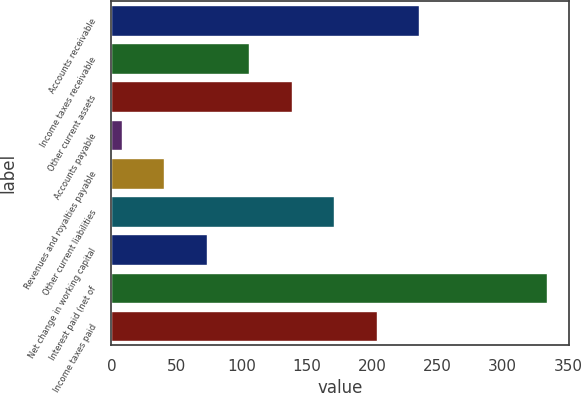<chart> <loc_0><loc_0><loc_500><loc_500><bar_chart><fcel>Accounts receivable<fcel>Income taxes receivable<fcel>Other current assets<fcel>Accounts payable<fcel>Revenues and royalties payable<fcel>Other current liabilities<fcel>Net change in working capital<fcel>Interest paid (net of<fcel>Income taxes paid<nl><fcel>236.2<fcel>105.8<fcel>138.4<fcel>8<fcel>40.6<fcel>171<fcel>73.2<fcel>334<fcel>203.6<nl></chart> 